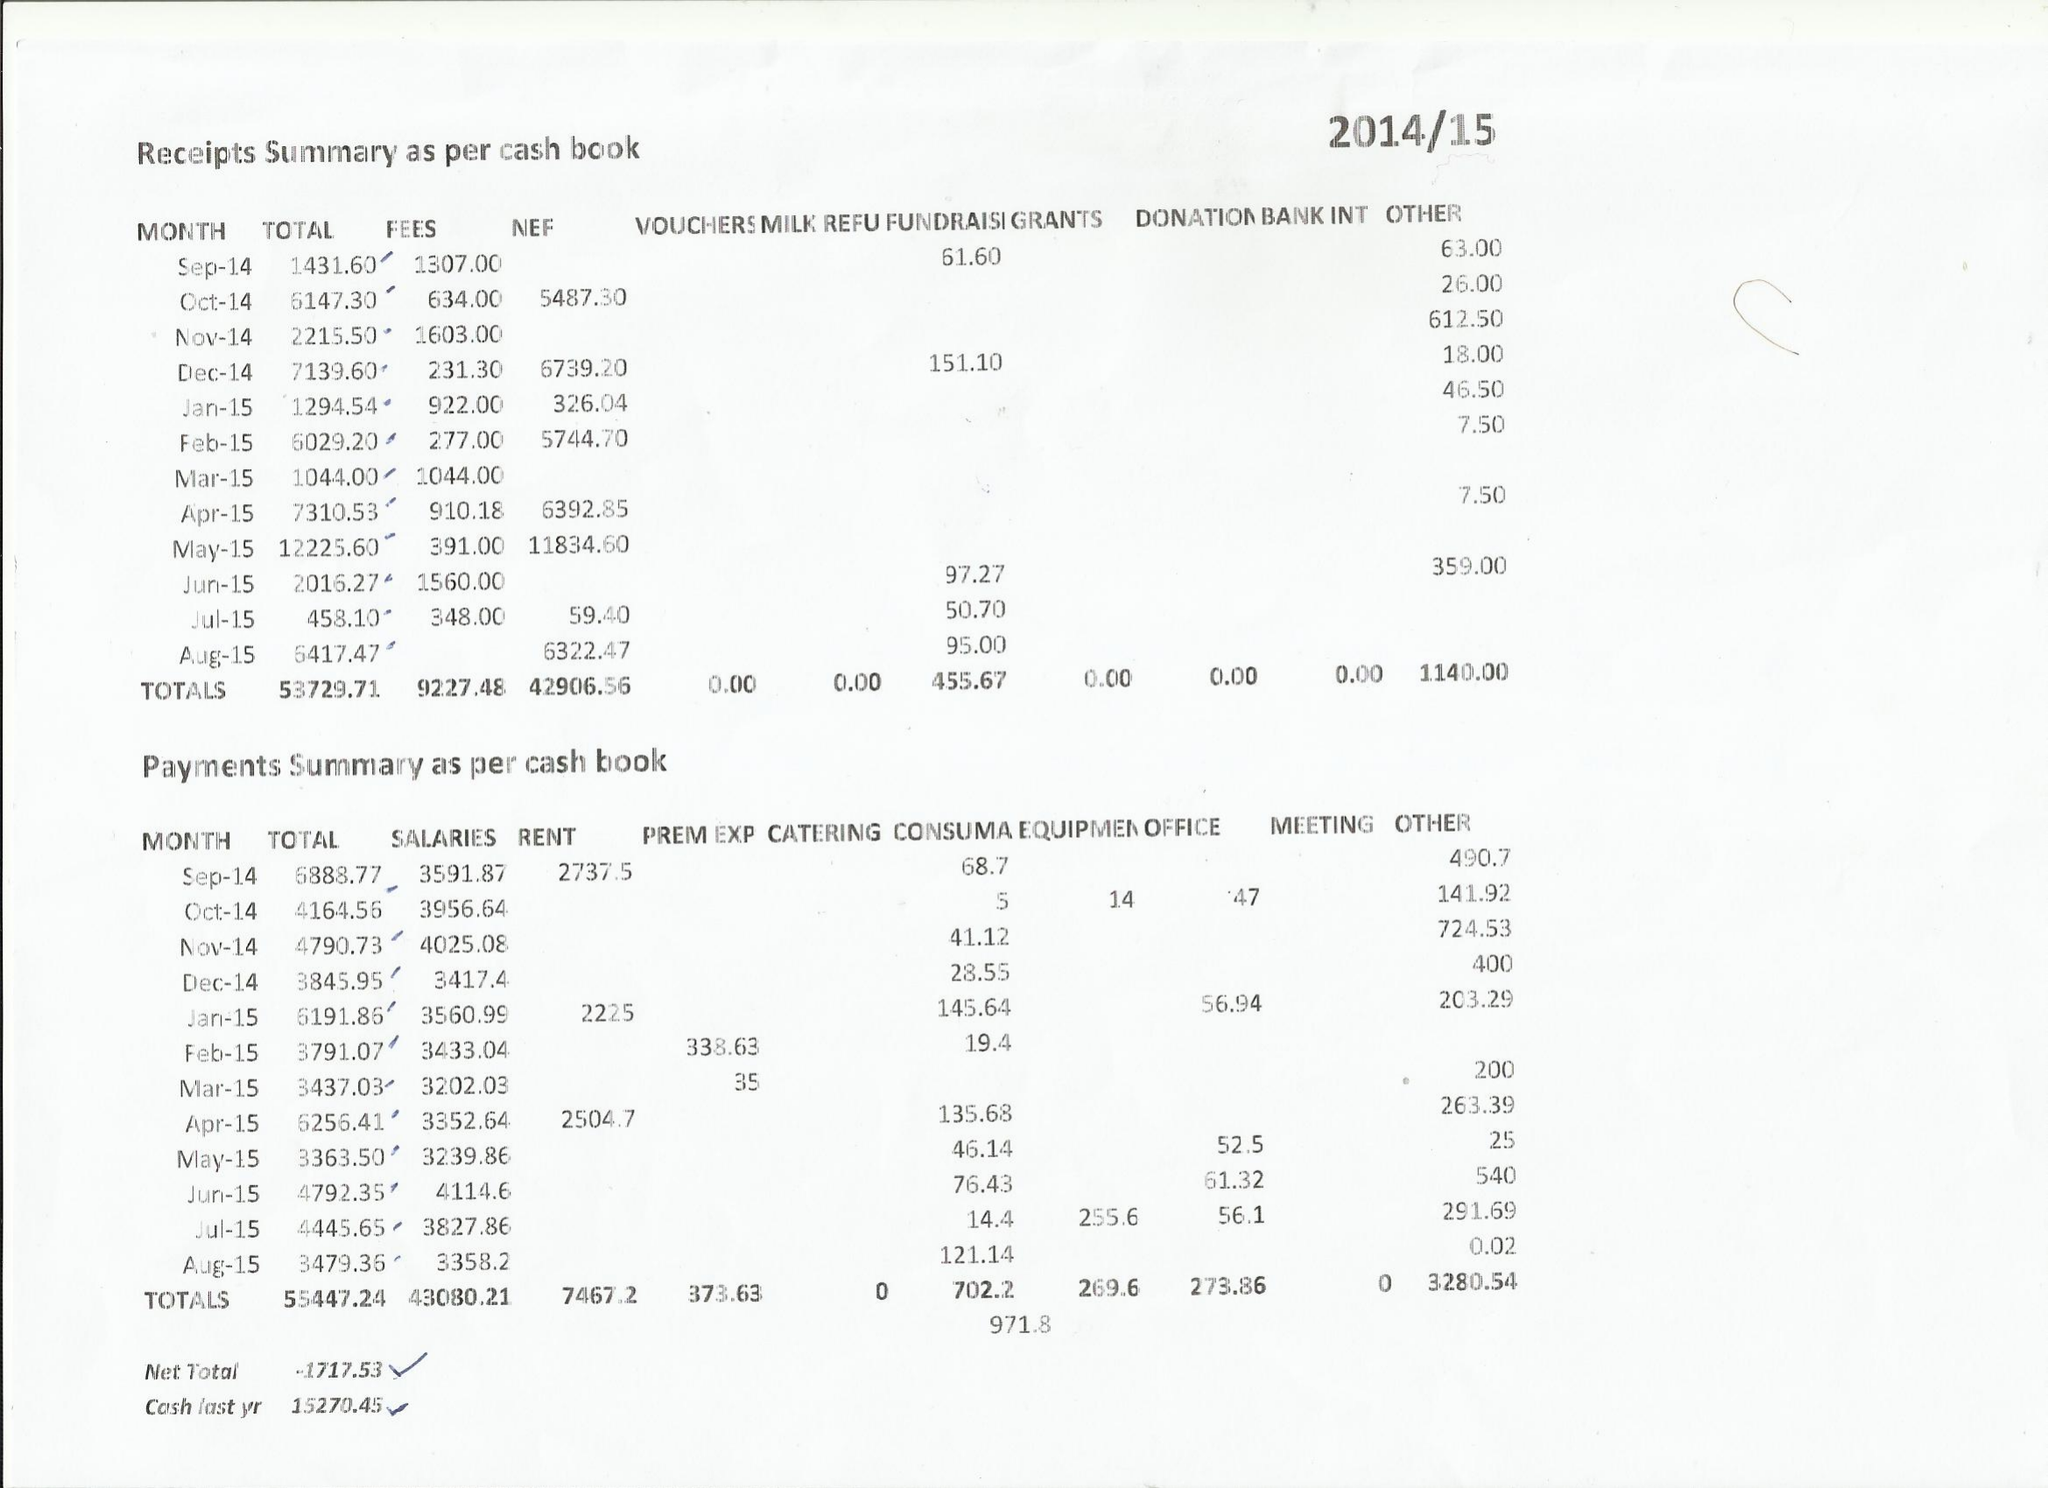What is the value for the report_date?
Answer the question using a single word or phrase. 2015-08-31 